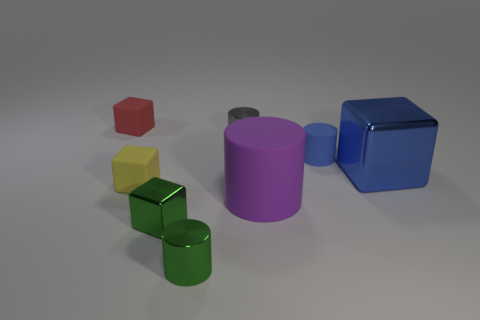Does the metal object that is behind the blue metallic block have the same size as the blue matte cylinder?
Provide a succinct answer. Yes. What size is the red object that is the same shape as the big blue metal object?
Your response must be concise. Small. Is there any other thing that has the same size as the purple cylinder?
Give a very brief answer. Yes. Is the tiny yellow matte thing the same shape as the purple matte thing?
Keep it short and to the point. No. Is the number of tiny red blocks in front of the tiny red block less than the number of tiny gray shiny things behind the small blue cylinder?
Provide a succinct answer. Yes. How many rubber things are to the right of the small red block?
Provide a succinct answer. 3. Is the shape of the shiny object in front of the small green shiny cube the same as the tiny shiny object behind the large matte object?
Give a very brief answer. Yes. What number of other objects are there of the same color as the big rubber cylinder?
Provide a short and direct response. 0. The thing to the left of the tiny rubber block in front of the matte block behind the blue block is made of what material?
Keep it short and to the point. Rubber. The big purple object that is in front of the matte cube that is in front of the tiny gray object is made of what material?
Your answer should be very brief. Rubber. 